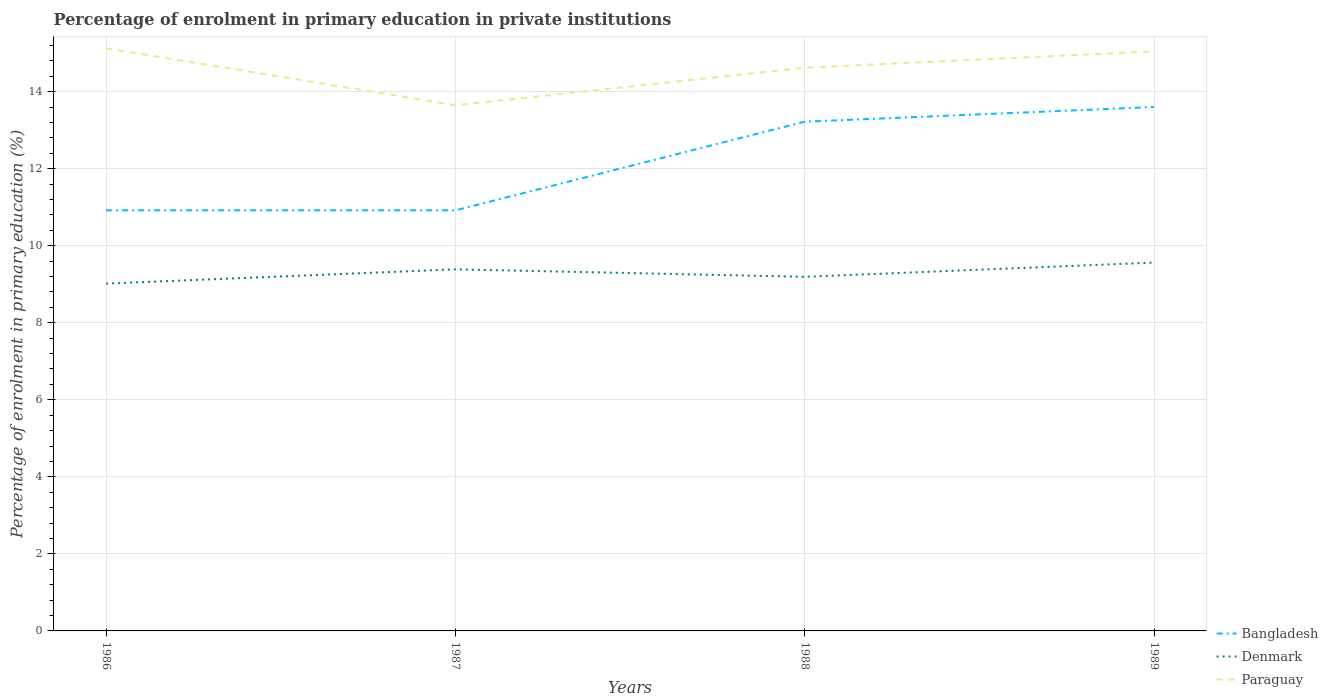Does the line corresponding to Paraguay intersect with the line corresponding to Bangladesh?
Offer a terse response. No. Is the number of lines equal to the number of legend labels?
Give a very brief answer. Yes. Across all years, what is the maximum percentage of enrolment in primary education in Paraguay?
Give a very brief answer. 13.65. In which year was the percentage of enrolment in primary education in Denmark maximum?
Provide a short and direct response. 1986. What is the total percentage of enrolment in primary education in Paraguay in the graph?
Provide a succinct answer. 0.5. What is the difference between the highest and the second highest percentage of enrolment in primary education in Paraguay?
Your answer should be very brief. 1.48. Is the percentage of enrolment in primary education in Denmark strictly greater than the percentage of enrolment in primary education in Paraguay over the years?
Offer a terse response. Yes. How many years are there in the graph?
Your response must be concise. 4. What is the difference between two consecutive major ticks on the Y-axis?
Provide a succinct answer. 2. Does the graph contain any zero values?
Give a very brief answer. No. Does the graph contain grids?
Give a very brief answer. Yes. Where does the legend appear in the graph?
Offer a very short reply. Bottom right. How many legend labels are there?
Give a very brief answer. 3. How are the legend labels stacked?
Make the answer very short. Vertical. What is the title of the graph?
Provide a short and direct response. Percentage of enrolment in primary education in private institutions. What is the label or title of the X-axis?
Your answer should be compact. Years. What is the label or title of the Y-axis?
Provide a succinct answer. Percentage of enrolment in primary education (%). What is the Percentage of enrolment in primary education (%) in Bangladesh in 1986?
Offer a very short reply. 10.92. What is the Percentage of enrolment in primary education (%) in Denmark in 1986?
Make the answer very short. 9.02. What is the Percentage of enrolment in primary education (%) in Paraguay in 1986?
Provide a short and direct response. 15.12. What is the Percentage of enrolment in primary education (%) in Bangladesh in 1987?
Offer a terse response. 10.92. What is the Percentage of enrolment in primary education (%) of Denmark in 1987?
Provide a short and direct response. 9.39. What is the Percentage of enrolment in primary education (%) of Paraguay in 1987?
Give a very brief answer. 13.65. What is the Percentage of enrolment in primary education (%) of Bangladesh in 1988?
Keep it short and to the point. 13.22. What is the Percentage of enrolment in primary education (%) of Denmark in 1988?
Your answer should be compact. 9.19. What is the Percentage of enrolment in primary education (%) of Paraguay in 1988?
Offer a terse response. 14.62. What is the Percentage of enrolment in primary education (%) in Bangladesh in 1989?
Provide a short and direct response. 13.6. What is the Percentage of enrolment in primary education (%) in Denmark in 1989?
Ensure brevity in your answer.  9.56. What is the Percentage of enrolment in primary education (%) in Paraguay in 1989?
Your answer should be very brief. 15.05. Across all years, what is the maximum Percentage of enrolment in primary education (%) in Bangladesh?
Make the answer very short. 13.6. Across all years, what is the maximum Percentage of enrolment in primary education (%) of Denmark?
Ensure brevity in your answer.  9.56. Across all years, what is the maximum Percentage of enrolment in primary education (%) in Paraguay?
Ensure brevity in your answer.  15.12. Across all years, what is the minimum Percentage of enrolment in primary education (%) in Bangladesh?
Make the answer very short. 10.92. Across all years, what is the minimum Percentage of enrolment in primary education (%) of Denmark?
Offer a very short reply. 9.02. Across all years, what is the minimum Percentage of enrolment in primary education (%) in Paraguay?
Your response must be concise. 13.65. What is the total Percentage of enrolment in primary education (%) of Bangladesh in the graph?
Provide a short and direct response. 48.66. What is the total Percentage of enrolment in primary education (%) in Denmark in the graph?
Offer a terse response. 37.16. What is the total Percentage of enrolment in primary education (%) in Paraguay in the graph?
Make the answer very short. 58.43. What is the difference between the Percentage of enrolment in primary education (%) of Bangladesh in 1986 and that in 1987?
Offer a terse response. -0. What is the difference between the Percentage of enrolment in primary education (%) of Denmark in 1986 and that in 1987?
Provide a succinct answer. -0.37. What is the difference between the Percentage of enrolment in primary education (%) in Paraguay in 1986 and that in 1987?
Your answer should be compact. 1.48. What is the difference between the Percentage of enrolment in primary education (%) of Bangladesh in 1986 and that in 1988?
Your answer should be compact. -2.3. What is the difference between the Percentage of enrolment in primary education (%) in Denmark in 1986 and that in 1988?
Make the answer very short. -0.18. What is the difference between the Percentage of enrolment in primary education (%) in Paraguay in 1986 and that in 1988?
Give a very brief answer. 0.5. What is the difference between the Percentage of enrolment in primary education (%) of Bangladesh in 1986 and that in 1989?
Offer a very short reply. -2.68. What is the difference between the Percentage of enrolment in primary education (%) of Denmark in 1986 and that in 1989?
Provide a succinct answer. -0.55. What is the difference between the Percentage of enrolment in primary education (%) of Paraguay in 1986 and that in 1989?
Provide a short and direct response. 0.08. What is the difference between the Percentage of enrolment in primary education (%) in Bangladesh in 1987 and that in 1988?
Give a very brief answer. -2.3. What is the difference between the Percentage of enrolment in primary education (%) of Denmark in 1987 and that in 1988?
Your response must be concise. 0.19. What is the difference between the Percentage of enrolment in primary education (%) of Paraguay in 1987 and that in 1988?
Your answer should be compact. -0.97. What is the difference between the Percentage of enrolment in primary education (%) in Bangladesh in 1987 and that in 1989?
Your answer should be very brief. -2.68. What is the difference between the Percentage of enrolment in primary education (%) of Denmark in 1987 and that in 1989?
Ensure brevity in your answer.  -0.18. What is the difference between the Percentage of enrolment in primary education (%) in Paraguay in 1987 and that in 1989?
Give a very brief answer. -1.4. What is the difference between the Percentage of enrolment in primary education (%) in Bangladesh in 1988 and that in 1989?
Make the answer very short. -0.38. What is the difference between the Percentage of enrolment in primary education (%) of Denmark in 1988 and that in 1989?
Provide a succinct answer. -0.37. What is the difference between the Percentage of enrolment in primary education (%) in Paraguay in 1988 and that in 1989?
Offer a very short reply. -0.42. What is the difference between the Percentage of enrolment in primary education (%) of Bangladesh in 1986 and the Percentage of enrolment in primary education (%) of Denmark in 1987?
Your answer should be very brief. 1.53. What is the difference between the Percentage of enrolment in primary education (%) of Bangladesh in 1986 and the Percentage of enrolment in primary education (%) of Paraguay in 1987?
Ensure brevity in your answer.  -2.73. What is the difference between the Percentage of enrolment in primary education (%) of Denmark in 1986 and the Percentage of enrolment in primary education (%) of Paraguay in 1987?
Ensure brevity in your answer.  -4.63. What is the difference between the Percentage of enrolment in primary education (%) in Bangladesh in 1986 and the Percentage of enrolment in primary education (%) in Denmark in 1988?
Ensure brevity in your answer.  1.73. What is the difference between the Percentage of enrolment in primary education (%) of Bangladesh in 1986 and the Percentage of enrolment in primary education (%) of Paraguay in 1988?
Your answer should be compact. -3.7. What is the difference between the Percentage of enrolment in primary education (%) of Denmark in 1986 and the Percentage of enrolment in primary education (%) of Paraguay in 1988?
Provide a short and direct response. -5.6. What is the difference between the Percentage of enrolment in primary education (%) in Bangladesh in 1986 and the Percentage of enrolment in primary education (%) in Denmark in 1989?
Your response must be concise. 1.36. What is the difference between the Percentage of enrolment in primary education (%) of Bangladesh in 1986 and the Percentage of enrolment in primary education (%) of Paraguay in 1989?
Your response must be concise. -4.13. What is the difference between the Percentage of enrolment in primary education (%) of Denmark in 1986 and the Percentage of enrolment in primary education (%) of Paraguay in 1989?
Offer a very short reply. -6.03. What is the difference between the Percentage of enrolment in primary education (%) in Bangladesh in 1987 and the Percentage of enrolment in primary education (%) in Denmark in 1988?
Offer a terse response. 1.73. What is the difference between the Percentage of enrolment in primary education (%) in Bangladesh in 1987 and the Percentage of enrolment in primary education (%) in Paraguay in 1988?
Offer a terse response. -3.7. What is the difference between the Percentage of enrolment in primary education (%) of Denmark in 1987 and the Percentage of enrolment in primary education (%) of Paraguay in 1988?
Offer a very short reply. -5.23. What is the difference between the Percentage of enrolment in primary education (%) in Bangladesh in 1987 and the Percentage of enrolment in primary education (%) in Denmark in 1989?
Keep it short and to the point. 1.36. What is the difference between the Percentage of enrolment in primary education (%) in Bangladesh in 1987 and the Percentage of enrolment in primary education (%) in Paraguay in 1989?
Your answer should be compact. -4.13. What is the difference between the Percentage of enrolment in primary education (%) of Denmark in 1987 and the Percentage of enrolment in primary education (%) of Paraguay in 1989?
Provide a short and direct response. -5.66. What is the difference between the Percentage of enrolment in primary education (%) of Bangladesh in 1988 and the Percentage of enrolment in primary education (%) of Denmark in 1989?
Offer a terse response. 3.66. What is the difference between the Percentage of enrolment in primary education (%) of Bangladesh in 1988 and the Percentage of enrolment in primary education (%) of Paraguay in 1989?
Give a very brief answer. -1.83. What is the difference between the Percentage of enrolment in primary education (%) in Denmark in 1988 and the Percentage of enrolment in primary education (%) in Paraguay in 1989?
Offer a very short reply. -5.85. What is the average Percentage of enrolment in primary education (%) of Bangladesh per year?
Your answer should be compact. 12.16. What is the average Percentage of enrolment in primary education (%) of Denmark per year?
Offer a very short reply. 9.29. What is the average Percentage of enrolment in primary education (%) in Paraguay per year?
Your answer should be compact. 14.61. In the year 1986, what is the difference between the Percentage of enrolment in primary education (%) of Bangladesh and Percentage of enrolment in primary education (%) of Denmark?
Give a very brief answer. 1.9. In the year 1986, what is the difference between the Percentage of enrolment in primary education (%) of Bangladesh and Percentage of enrolment in primary education (%) of Paraguay?
Your response must be concise. -4.2. In the year 1986, what is the difference between the Percentage of enrolment in primary education (%) in Denmark and Percentage of enrolment in primary education (%) in Paraguay?
Provide a succinct answer. -6.11. In the year 1987, what is the difference between the Percentage of enrolment in primary education (%) in Bangladesh and Percentage of enrolment in primary education (%) in Denmark?
Provide a short and direct response. 1.53. In the year 1987, what is the difference between the Percentage of enrolment in primary education (%) in Bangladesh and Percentage of enrolment in primary education (%) in Paraguay?
Offer a very short reply. -2.73. In the year 1987, what is the difference between the Percentage of enrolment in primary education (%) of Denmark and Percentage of enrolment in primary education (%) of Paraguay?
Offer a very short reply. -4.26. In the year 1988, what is the difference between the Percentage of enrolment in primary education (%) in Bangladesh and Percentage of enrolment in primary education (%) in Denmark?
Your answer should be compact. 4.03. In the year 1988, what is the difference between the Percentage of enrolment in primary education (%) in Bangladesh and Percentage of enrolment in primary education (%) in Paraguay?
Keep it short and to the point. -1.4. In the year 1988, what is the difference between the Percentage of enrolment in primary education (%) of Denmark and Percentage of enrolment in primary education (%) of Paraguay?
Offer a terse response. -5.43. In the year 1989, what is the difference between the Percentage of enrolment in primary education (%) in Bangladesh and Percentage of enrolment in primary education (%) in Denmark?
Keep it short and to the point. 4.04. In the year 1989, what is the difference between the Percentage of enrolment in primary education (%) in Bangladesh and Percentage of enrolment in primary education (%) in Paraguay?
Offer a very short reply. -1.44. In the year 1989, what is the difference between the Percentage of enrolment in primary education (%) of Denmark and Percentage of enrolment in primary education (%) of Paraguay?
Your answer should be very brief. -5.48. What is the ratio of the Percentage of enrolment in primary education (%) in Bangladesh in 1986 to that in 1987?
Ensure brevity in your answer.  1. What is the ratio of the Percentage of enrolment in primary education (%) in Denmark in 1986 to that in 1987?
Provide a short and direct response. 0.96. What is the ratio of the Percentage of enrolment in primary education (%) of Paraguay in 1986 to that in 1987?
Your response must be concise. 1.11. What is the ratio of the Percentage of enrolment in primary education (%) of Bangladesh in 1986 to that in 1988?
Your response must be concise. 0.83. What is the ratio of the Percentage of enrolment in primary education (%) in Denmark in 1986 to that in 1988?
Give a very brief answer. 0.98. What is the ratio of the Percentage of enrolment in primary education (%) in Paraguay in 1986 to that in 1988?
Offer a very short reply. 1.03. What is the ratio of the Percentage of enrolment in primary education (%) of Bangladesh in 1986 to that in 1989?
Ensure brevity in your answer.  0.8. What is the ratio of the Percentage of enrolment in primary education (%) of Denmark in 1986 to that in 1989?
Provide a short and direct response. 0.94. What is the ratio of the Percentage of enrolment in primary education (%) in Paraguay in 1986 to that in 1989?
Provide a short and direct response. 1.01. What is the ratio of the Percentage of enrolment in primary education (%) in Bangladesh in 1987 to that in 1988?
Your response must be concise. 0.83. What is the ratio of the Percentage of enrolment in primary education (%) in Denmark in 1987 to that in 1988?
Your response must be concise. 1.02. What is the ratio of the Percentage of enrolment in primary education (%) in Paraguay in 1987 to that in 1988?
Keep it short and to the point. 0.93. What is the ratio of the Percentage of enrolment in primary education (%) of Bangladesh in 1987 to that in 1989?
Give a very brief answer. 0.8. What is the ratio of the Percentage of enrolment in primary education (%) of Denmark in 1987 to that in 1989?
Your answer should be very brief. 0.98. What is the ratio of the Percentage of enrolment in primary education (%) of Paraguay in 1987 to that in 1989?
Offer a very short reply. 0.91. What is the ratio of the Percentage of enrolment in primary education (%) of Denmark in 1988 to that in 1989?
Give a very brief answer. 0.96. What is the ratio of the Percentage of enrolment in primary education (%) of Paraguay in 1988 to that in 1989?
Provide a succinct answer. 0.97. What is the difference between the highest and the second highest Percentage of enrolment in primary education (%) of Bangladesh?
Give a very brief answer. 0.38. What is the difference between the highest and the second highest Percentage of enrolment in primary education (%) in Denmark?
Make the answer very short. 0.18. What is the difference between the highest and the second highest Percentage of enrolment in primary education (%) of Paraguay?
Your answer should be very brief. 0.08. What is the difference between the highest and the lowest Percentage of enrolment in primary education (%) of Bangladesh?
Ensure brevity in your answer.  2.68. What is the difference between the highest and the lowest Percentage of enrolment in primary education (%) in Denmark?
Make the answer very short. 0.55. What is the difference between the highest and the lowest Percentage of enrolment in primary education (%) in Paraguay?
Your answer should be very brief. 1.48. 